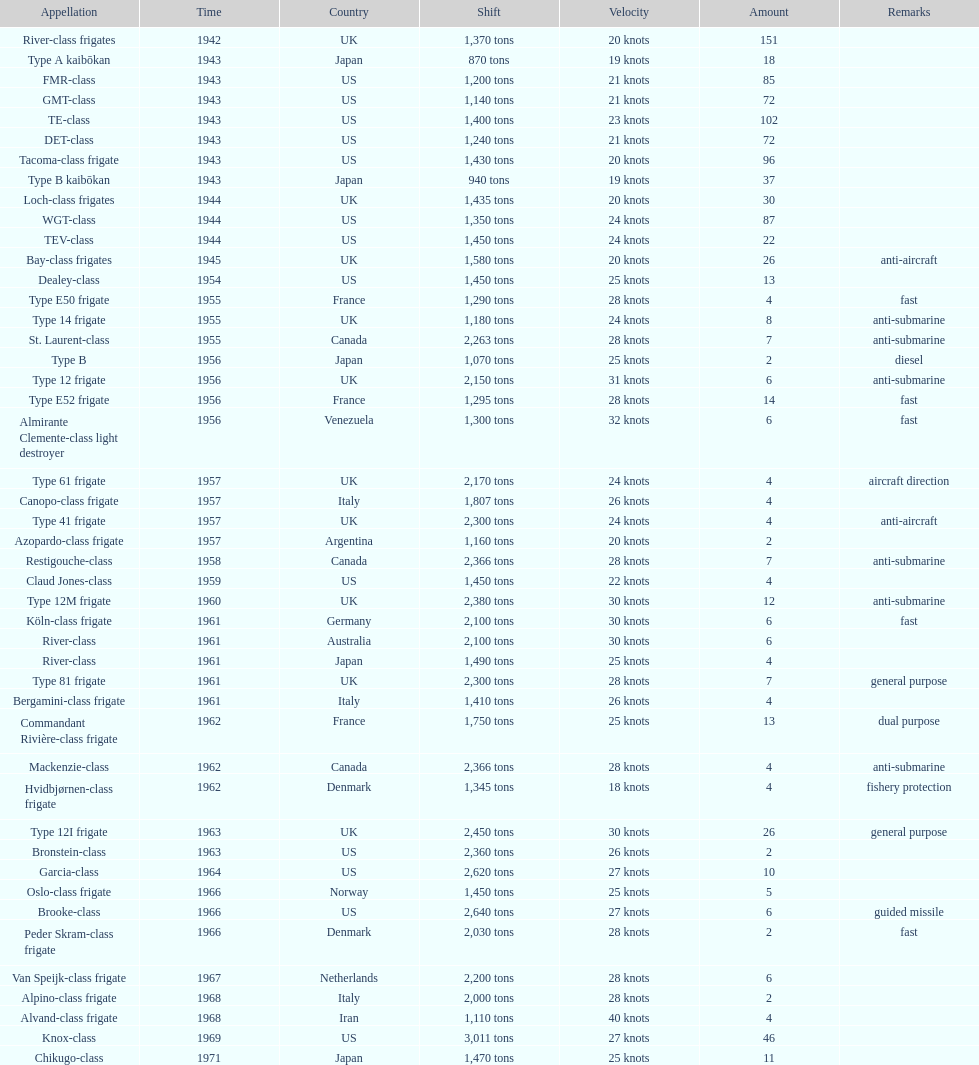Which name has the largest displacement? Knox-class. Could you help me parse every detail presented in this table? {'header': ['Appellation', 'Time', 'Country', 'Shift', 'Velocity', 'Amount', 'Remarks'], 'rows': [['River-class frigates', '1942', 'UK', '1,370 tons', '20 knots', '151', ''], ['Type A kaibōkan', '1943', 'Japan', '870 tons', '19 knots', '18', ''], ['FMR-class', '1943', 'US', '1,200 tons', '21 knots', '85', ''], ['GMT-class', '1943', 'US', '1,140 tons', '21 knots', '72', ''], ['TE-class', '1943', 'US', '1,400 tons', '23 knots', '102', ''], ['DET-class', '1943', 'US', '1,240 tons', '21 knots', '72', ''], ['Tacoma-class frigate', '1943', 'US', '1,430 tons', '20 knots', '96', ''], ['Type B kaibōkan', '1943', 'Japan', '940 tons', '19 knots', '37', ''], ['Loch-class frigates', '1944', 'UK', '1,435 tons', '20 knots', '30', ''], ['WGT-class', '1944', 'US', '1,350 tons', '24 knots', '87', ''], ['TEV-class', '1944', 'US', '1,450 tons', '24 knots', '22', ''], ['Bay-class frigates', '1945', 'UK', '1,580 tons', '20 knots', '26', 'anti-aircraft'], ['Dealey-class', '1954', 'US', '1,450 tons', '25 knots', '13', ''], ['Type E50 frigate', '1955', 'France', '1,290 tons', '28 knots', '4', 'fast'], ['Type 14 frigate', '1955', 'UK', '1,180 tons', '24 knots', '8', 'anti-submarine'], ['St. Laurent-class', '1955', 'Canada', '2,263 tons', '28 knots', '7', 'anti-submarine'], ['Type B', '1956', 'Japan', '1,070 tons', '25 knots', '2', 'diesel'], ['Type 12 frigate', '1956', 'UK', '2,150 tons', '31 knots', '6', 'anti-submarine'], ['Type E52 frigate', '1956', 'France', '1,295 tons', '28 knots', '14', 'fast'], ['Almirante Clemente-class light destroyer', '1956', 'Venezuela', '1,300 tons', '32 knots', '6', 'fast'], ['Type 61 frigate', '1957', 'UK', '2,170 tons', '24 knots', '4', 'aircraft direction'], ['Canopo-class frigate', '1957', 'Italy', '1,807 tons', '26 knots', '4', ''], ['Type 41 frigate', '1957', 'UK', '2,300 tons', '24 knots', '4', 'anti-aircraft'], ['Azopardo-class frigate', '1957', 'Argentina', '1,160 tons', '20 knots', '2', ''], ['Restigouche-class', '1958', 'Canada', '2,366 tons', '28 knots', '7', 'anti-submarine'], ['Claud Jones-class', '1959', 'US', '1,450 tons', '22 knots', '4', ''], ['Type 12M frigate', '1960', 'UK', '2,380 tons', '30 knots', '12', 'anti-submarine'], ['Köln-class frigate', '1961', 'Germany', '2,100 tons', '30 knots', '6', 'fast'], ['River-class', '1961', 'Australia', '2,100 tons', '30 knots', '6', ''], ['River-class', '1961', 'Japan', '1,490 tons', '25 knots', '4', ''], ['Type 81 frigate', '1961', 'UK', '2,300 tons', '28 knots', '7', 'general purpose'], ['Bergamini-class frigate', '1961', 'Italy', '1,410 tons', '26 knots', '4', ''], ['Commandant Rivière-class frigate', '1962', 'France', '1,750 tons', '25 knots', '13', 'dual purpose'], ['Mackenzie-class', '1962', 'Canada', '2,366 tons', '28 knots', '4', 'anti-submarine'], ['Hvidbjørnen-class frigate', '1962', 'Denmark', '1,345 tons', '18 knots', '4', 'fishery protection'], ['Type 12I frigate', '1963', 'UK', '2,450 tons', '30 knots', '26', 'general purpose'], ['Bronstein-class', '1963', 'US', '2,360 tons', '26 knots', '2', ''], ['Garcia-class', '1964', 'US', '2,620 tons', '27 knots', '10', ''], ['Oslo-class frigate', '1966', 'Norway', '1,450 tons', '25 knots', '5', ''], ['Brooke-class', '1966', 'US', '2,640 tons', '27 knots', '6', 'guided missile'], ['Peder Skram-class frigate', '1966', 'Denmark', '2,030 tons', '28 knots', '2', 'fast'], ['Van Speijk-class frigate', '1967', 'Netherlands', '2,200 tons', '28 knots', '6', ''], ['Alpino-class frigate', '1968', 'Italy', '2,000 tons', '28 knots', '2', ''], ['Alvand-class frigate', '1968', 'Iran', '1,110 tons', '40 knots', '4', ''], ['Knox-class', '1969', 'US', '3,011 tons', '27 knots', '46', ''], ['Chikugo-class', '1971', 'Japan', '1,470 tons', '25 knots', '11', '']]} 